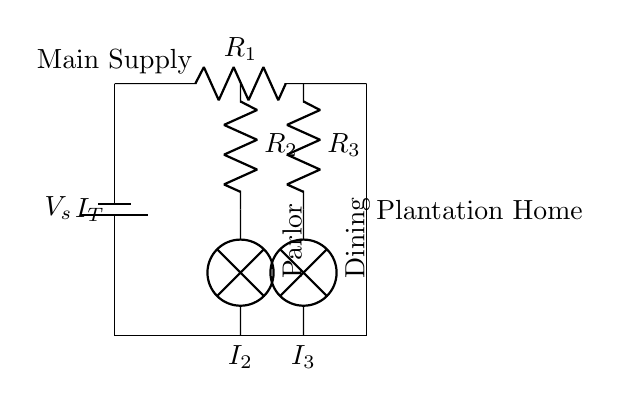What type of circuit is shown? The circuit diagram illustrates a parallel circuit, where the components are connected across the same voltage source and current is divided among the parallel branches.
Answer: Parallel circuit What is the resistance of the lamp in the parlor? The diagram does not specify the individual resistance of the lamp, but it shows that the branching components have a resistor labeled R2 in the parlor branch.
Answer: R2 What is the sum of the currents in the parlor and dining branches? The diagram shows two currents, I2 and I3, flowing through the parlor and dining lamps respectively. According to the current divider rule, the sum of these currents is equal to the total current (I_T) coming from the main supply.
Answer: I_T How many branches are there for lighting in the circuit? The diagram depicts two branches from the main circuit for lighting: one for the parlor and one for the dining room.
Answer: Two branches What is the role of resistor R1 in the circuit? Resistor R1 is the main resistor controlling the current flowing into the parallel branches, affecting the total current distribution in the circuit.
Answer: Current control What determines the current in each branch of this circuit? The current in each branch is determined by the resistance values of the components (R2 and R3) in the parallel configuration, as Ohm's Law explains that lower resistance will allow a higher current through that branch.
Answer: Resistance values What does the term "current divider" refer to in this circuit? The term "current divider" refers to the concept that the total current entering a parallel circuit is divided among the various branches based on the resistance in each branch, following the principle that the voltage across all branches is the same.
Answer: Current distribution 